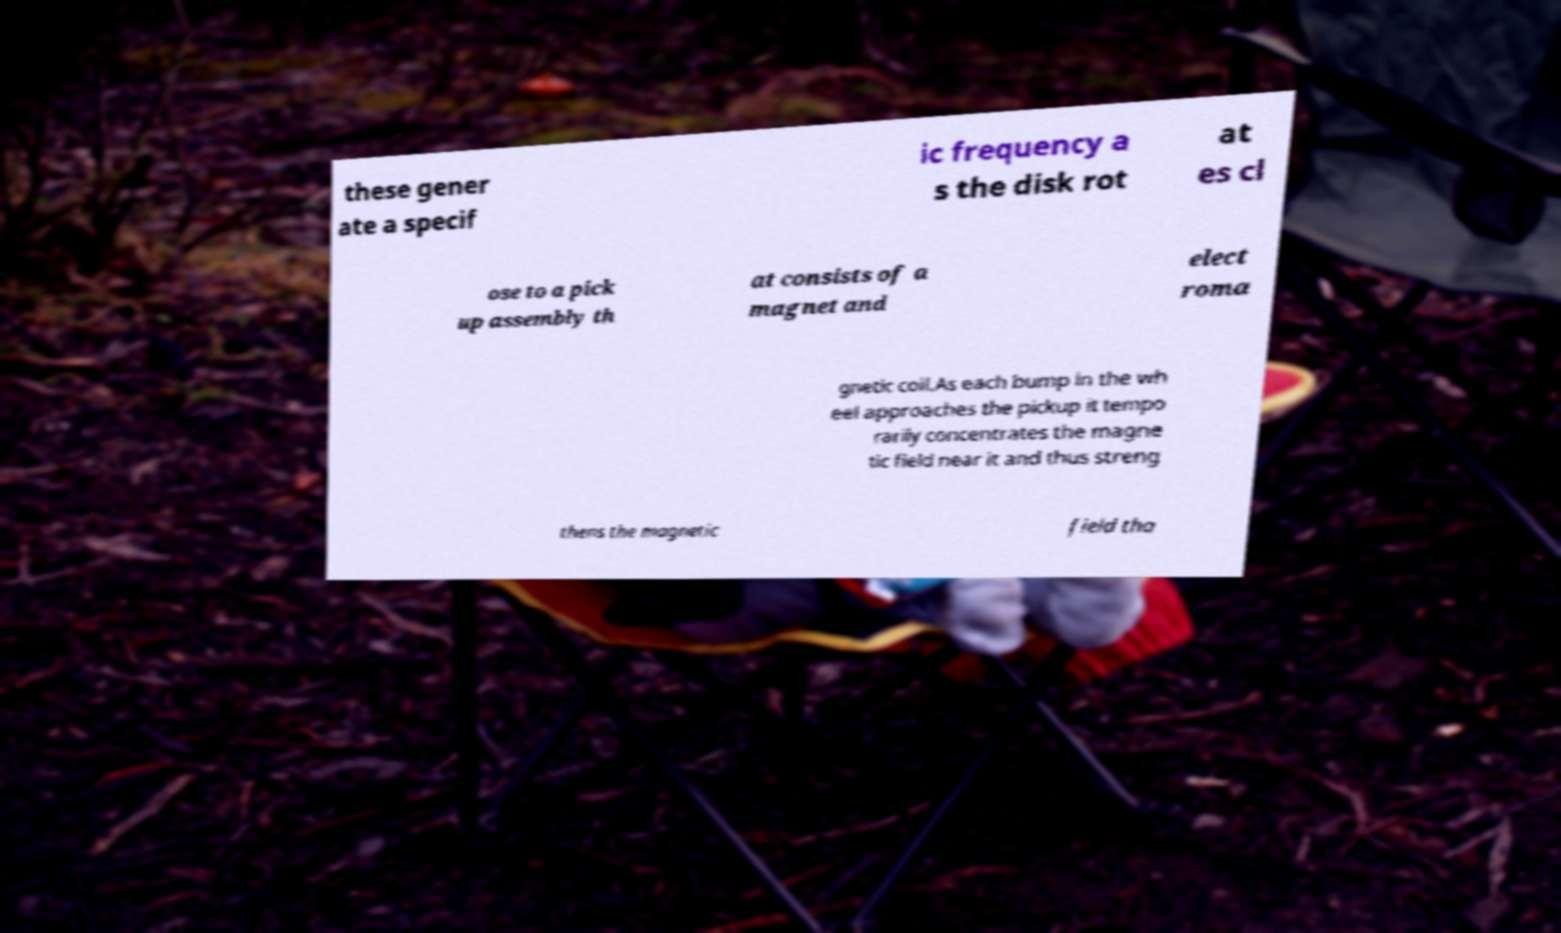I need the written content from this picture converted into text. Can you do that? these gener ate a specif ic frequency a s the disk rot at es cl ose to a pick up assembly th at consists of a magnet and elect roma gnetic coil.As each bump in the wh eel approaches the pickup it tempo rarily concentrates the magne tic field near it and thus streng thens the magnetic field tha 